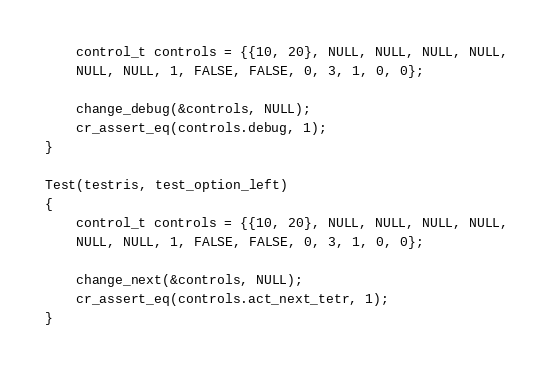Convert code to text. <code><loc_0><loc_0><loc_500><loc_500><_C_>	control_t controls = {{10, 20}, NULL, NULL, NULL, NULL,
	NULL, NULL, 1, FALSE, FALSE, 0, 3, 1, 0, 0};

	change_debug(&controls, NULL);
	cr_assert_eq(controls.debug, 1);
}

Test(testris, test_option_left)
{
	control_t controls = {{10, 20}, NULL, NULL, NULL, NULL,
	NULL, NULL, 1, FALSE, FALSE, 0, 3, 1, 0, 0};

	change_next(&controls, NULL);
	cr_assert_eq(controls.act_next_tetr, 1);
}</code> 